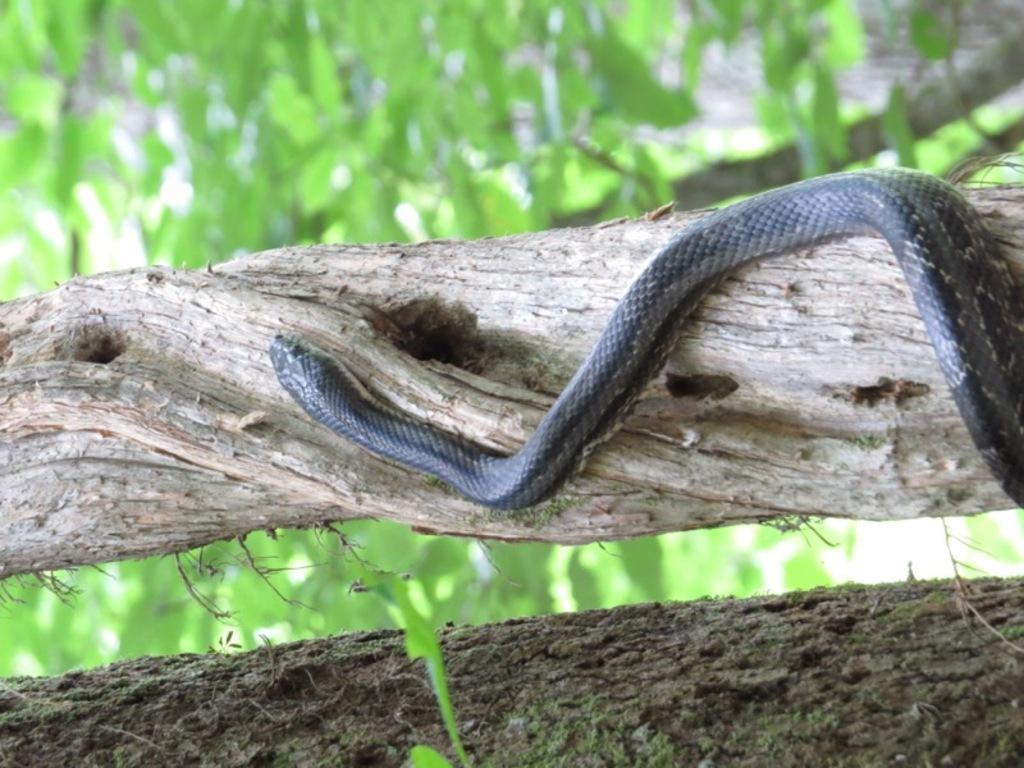How would you summarize this image in a sentence or two? In this image we can see a snake crawling on the trunk surface of the tree. And in the background, we can see some trees. 